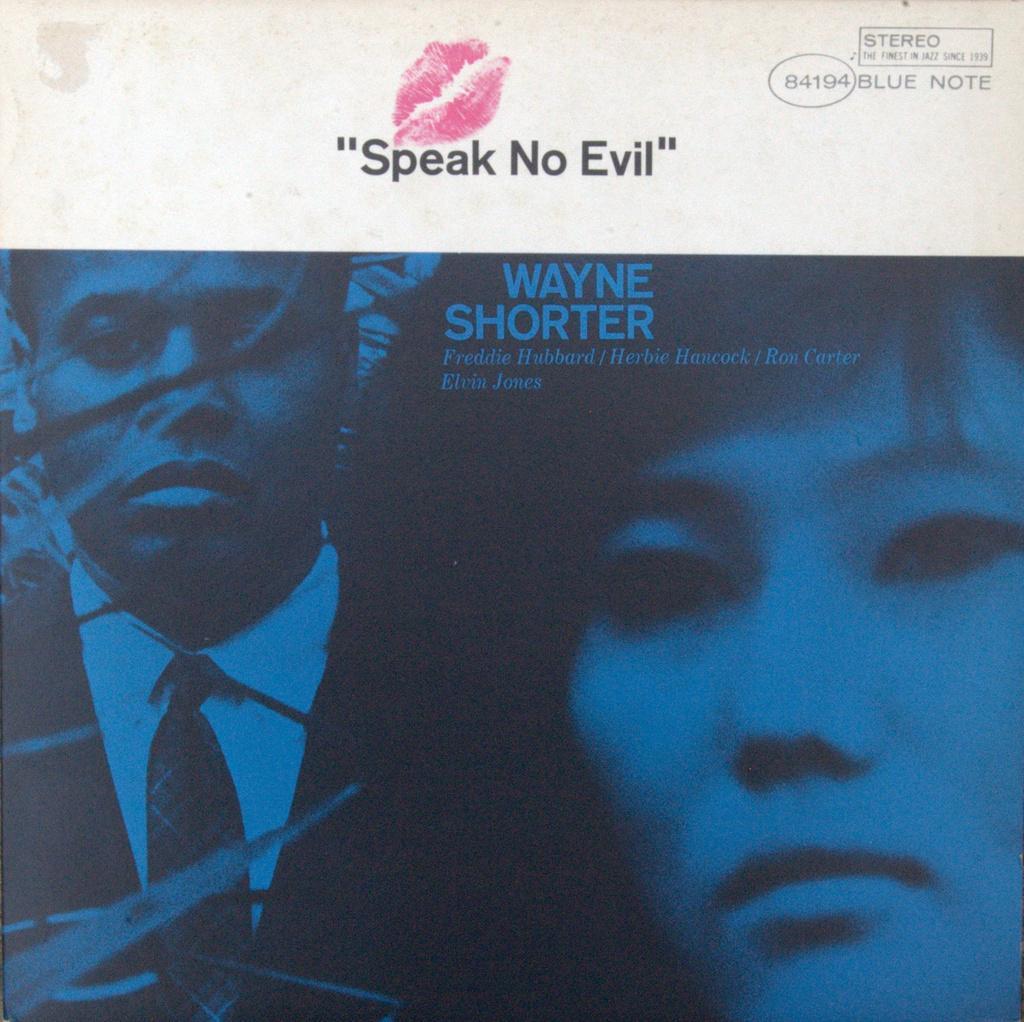Could you give a brief overview of what you see in this image? In this picture I can see a poster with words, numbers, image of two persons and a lipstick mark on it. 